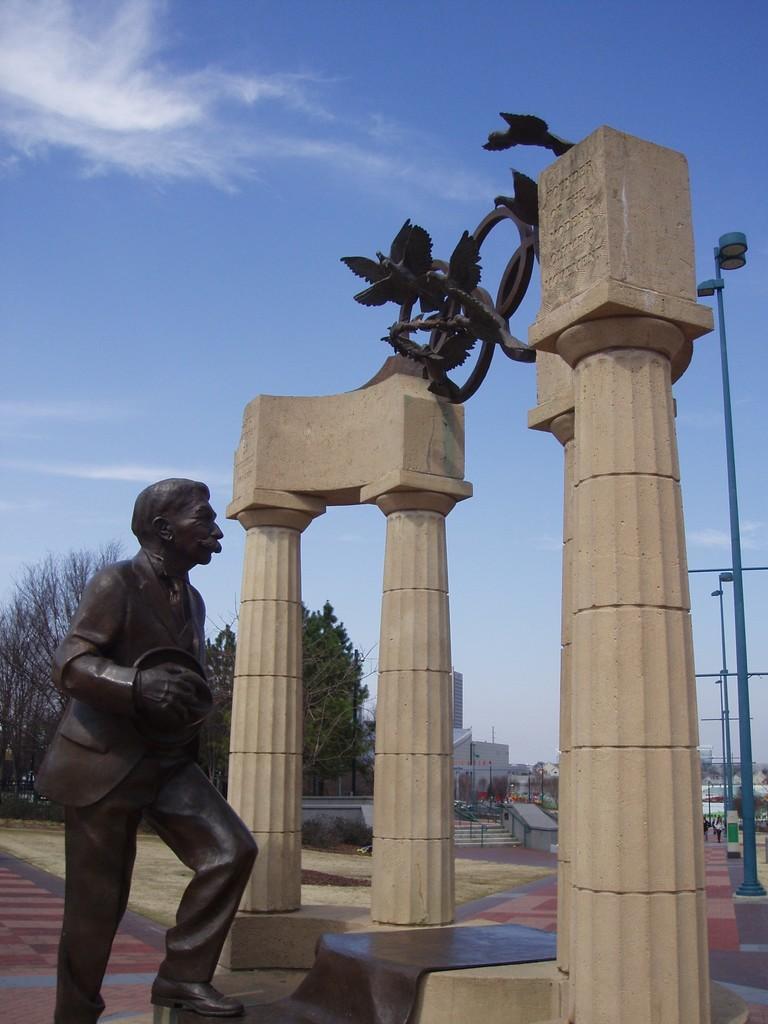In one or two sentences, can you explain what this image depicts? In this picture we can see a statue of a man, pillars, poles, steps, buildings, trees and in the background we can see the sky with clouds. 